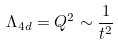Convert formula to latex. <formula><loc_0><loc_0><loc_500><loc_500>\Lambda _ { 4 d } = Q ^ { 2 } \sim \frac { 1 } { t ^ { 2 } }</formula> 